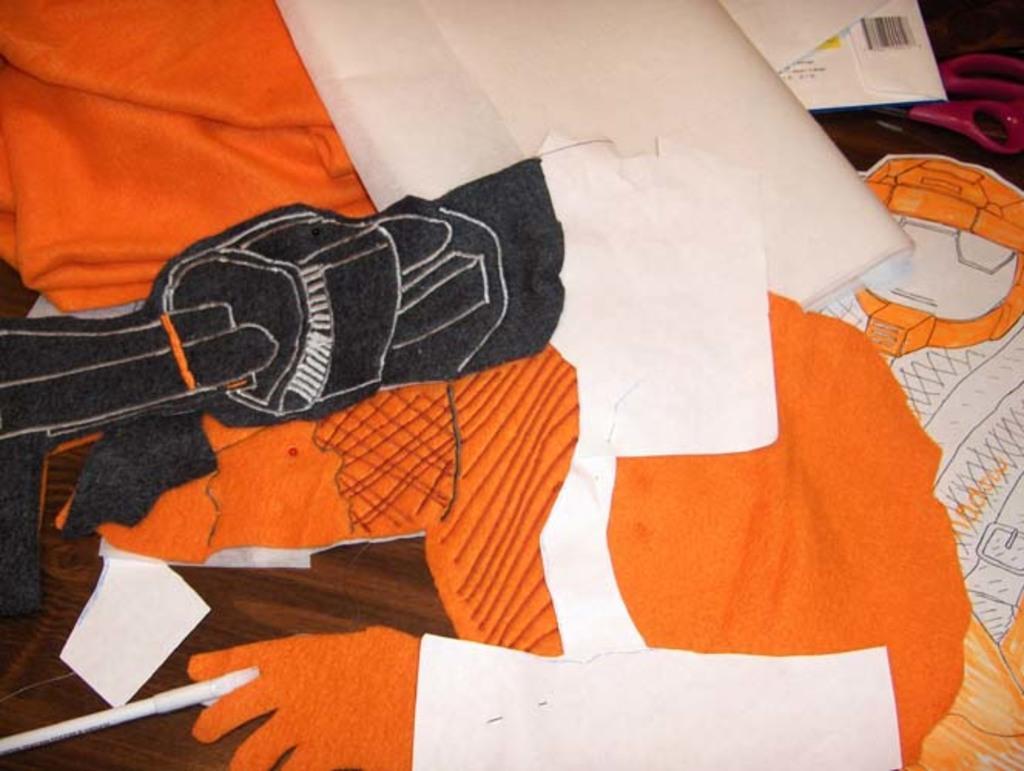Could you give a brief overview of what you see in this image? These are the clothes in orange color. 